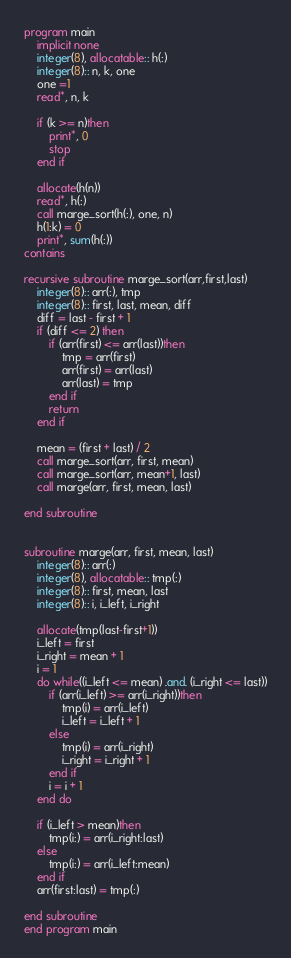Convert code to text. <code><loc_0><loc_0><loc_500><loc_500><_FORTRAN_>program main
    implicit none
    integer(8), allocatable:: h(:)
    integer(8):: n, k, one
    one =1
    read*, n, k
    
    if (k >= n)then
        print*, 0
        stop
    end if
    
    allocate(h(n))
    read*, h(:)
    call marge_sort(h(:), one, n)
    h(1:k) = 0
    print*, sum(h(:))
contains

recursive subroutine marge_sort(arr,first,last)
    integer(8):: arr(:), tmp
    integer(8):: first, last, mean, diff
    diff = last - first + 1
    if (diff <= 2) then
        if (arr(first) <= arr(last))then
            tmp = arr(first)
            arr(first) = arr(last)
            arr(last) = tmp
        end if
        return
    end if
    
    mean = (first + last) / 2
    call marge_sort(arr, first, mean)
    call marge_sort(arr, mean+1, last)
    call marge(arr, first, mean, last)

end subroutine


subroutine marge(arr, first, mean, last)
    integer(8):: arr(:)
    integer(8), allocatable:: tmp(:)
    integer(8):: first, mean, last
    integer(8):: i, i_left, i_right
    
    allocate(tmp(last-first+1))
    i_left = first
    i_right = mean + 1
    i = 1
    do while((i_left <= mean) .and. (i_right <= last))
        if (arr(i_left) >= arr(i_right))then
            tmp(i) = arr(i_left)
            i_left = i_left + 1
        else
            tmp(i) = arr(i_right)
            i_right = i_right + 1
        end if
        i = i + 1
    end do

    if (i_left > mean)then
        tmp(i:) = arr(i_right:last)
    else
        tmp(i:) = arr(i_left:mean)
    end if
    arr(first:last) = tmp(:)

end subroutine
end program main</code> 